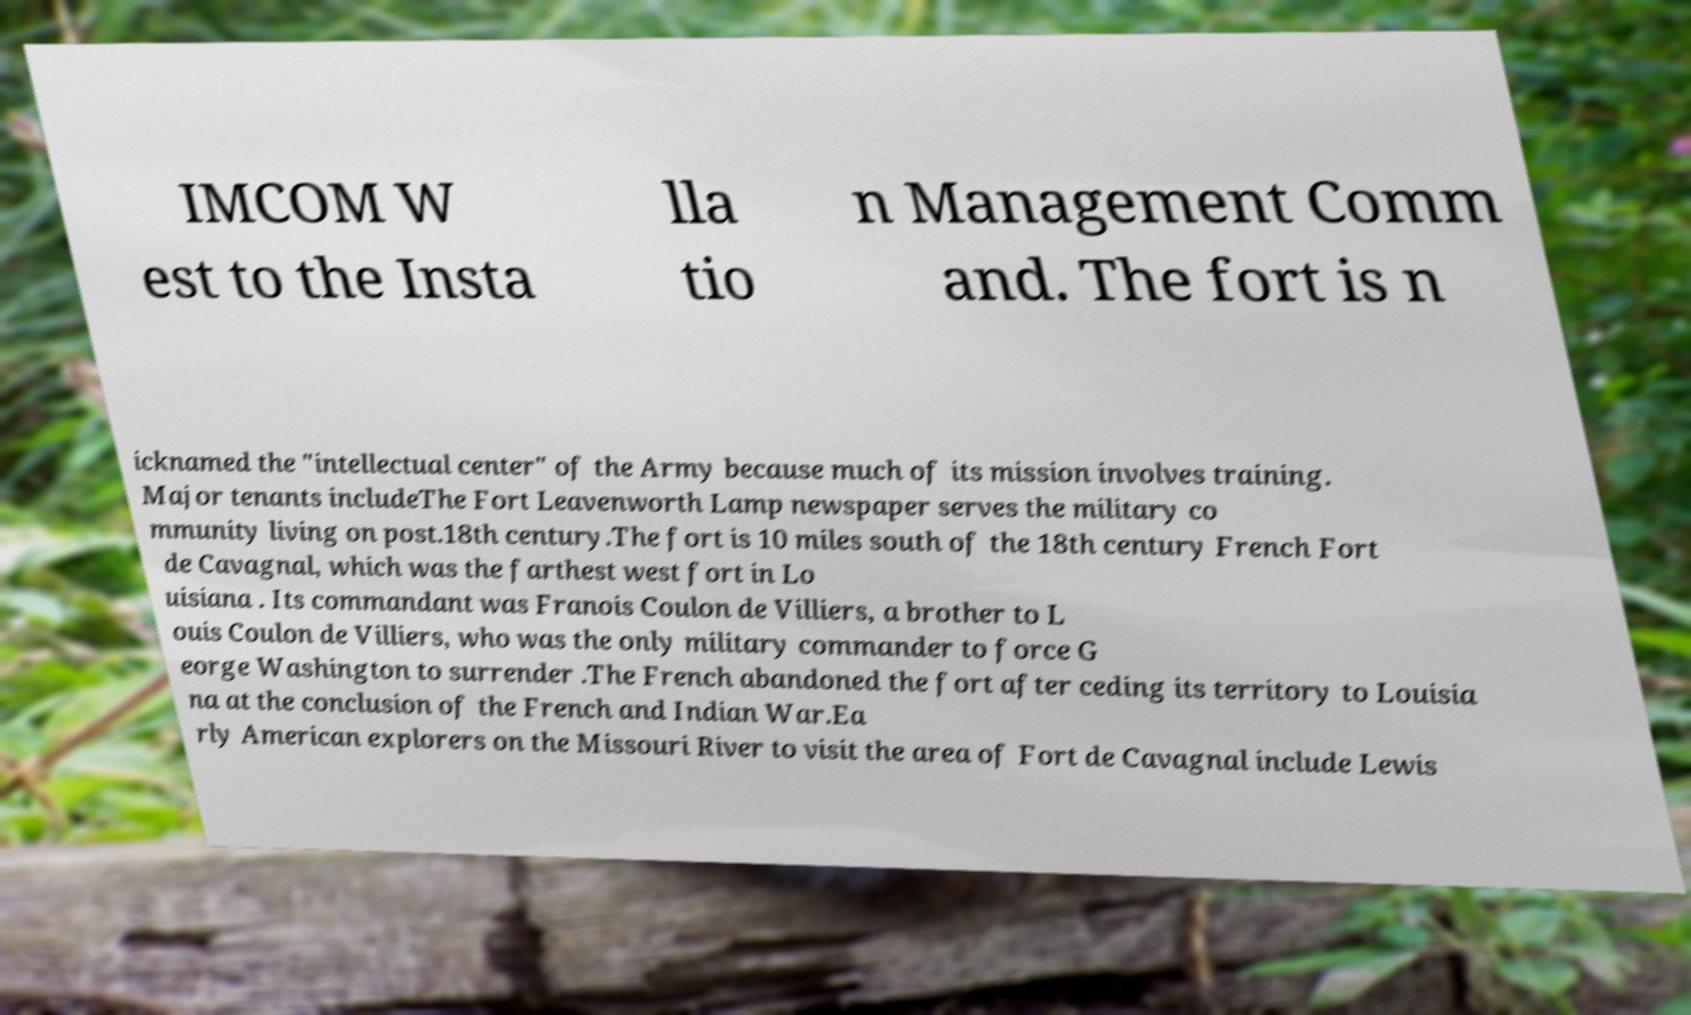Can you accurately transcribe the text from the provided image for me? IMCOM W est to the Insta lla tio n Management Comm and. The fort is n icknamed the "intellectual center" of the Army because much of its mission involves training. Major tenants includeThe Fort Leavenworth Lamp newspaper serves the military co mmunity living on post.18th century.The fort is 10 miles south of the 18th century French Fort de Cavagnal, which was the farthest west fort in Lo uisiana . Its commandant was Franois Coulon de Villiers, a brother to L ouis Coulon de Villiers, who was the only military commander to force G eorge Washington to surrender .The French abandoned the fort after ceding its territory to Louisia na at the conclusion of the French and Indian War.Ea rly American explorers on the Missouri River to visit the area of Fort de Cavagnal include Lewis 